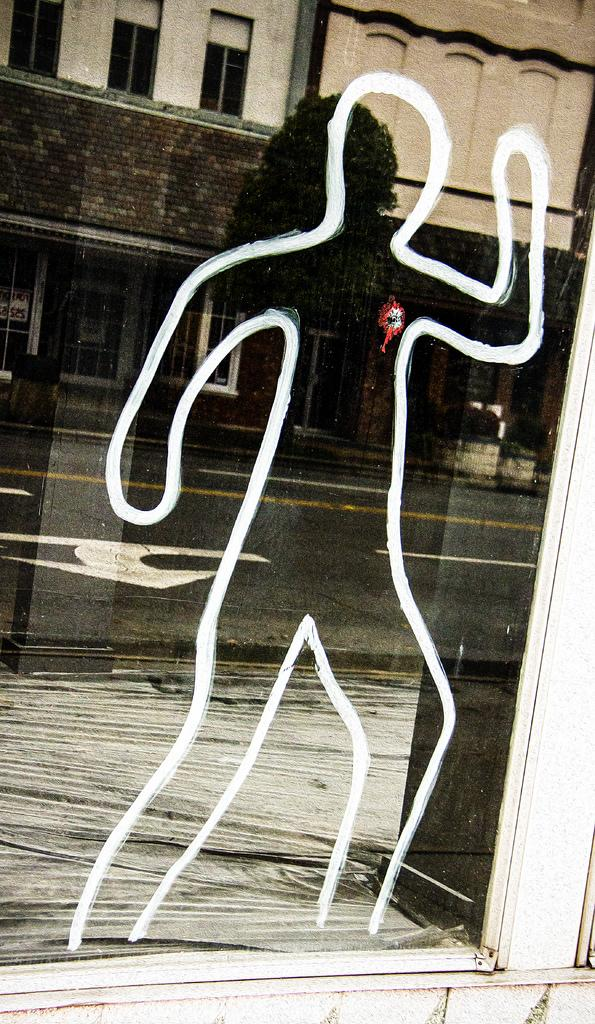What object is present in the image that can reflect images? There is a mirror in the image. What does the mirror reflect in the image? The mirror reflects a road, trees, and a building in the image. What type of plant can be seen growing in the mirror? There are no plants visible in the mirror; it reflects the road, trees, and building. 